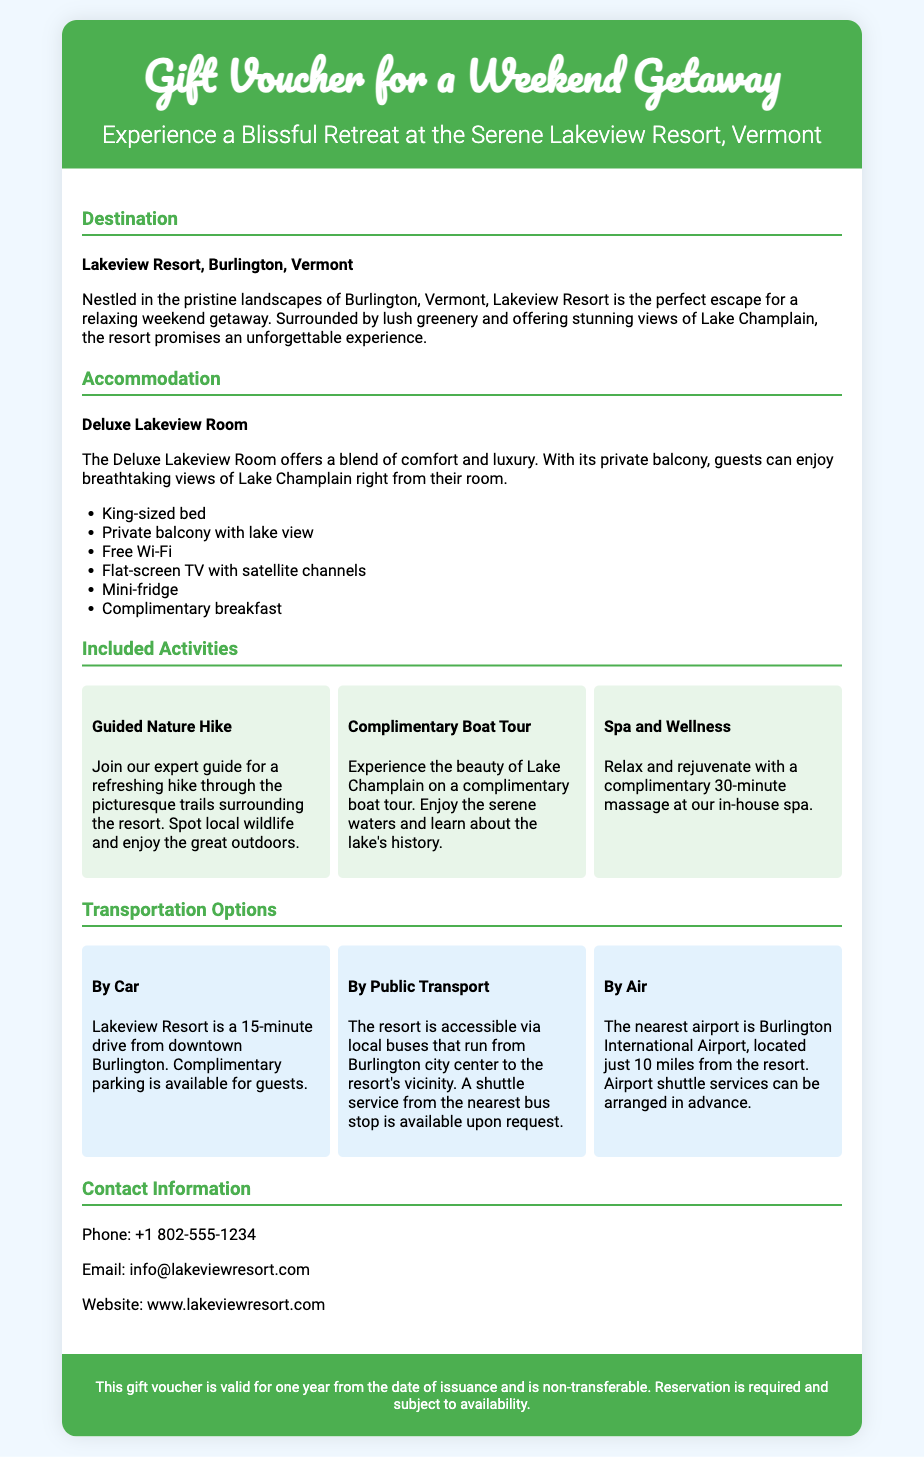what is the destination of the weekend getaway? The destination is mentioned in the header of the document, specifically stating "Lakeview Resort, Burlington, Vermont."
Answer: Lakeview Resort, Burlington, Vermont what type of room is included in the accommodation? The document specifies the accommodation type in the section about accommodation, which is "Deluxe Lakeview Room."
Answer: Deluxe Lakeview Room how many activities are included in the voucher? The document lists three specific activities under the "Included Activities" section.
Answer: Three what complimentary service is offered at the in-house spa? The document describes a specific service included in the activities, which is a massage.
Answer: 30-minute massage how far is the resort from the nearest airport? The document provides information about the airport distance in the transportation section, stating that it is "just 10 miles from the resort."
Answer: 10 miles what type of transport is available from Burlington city center? The document describes access to the resort via local buses in the transportation options.
Answer: Local buses what does the voucher mention about its validity? The footer of the voucher provides important details regarding the voucher's validity.
Answer: One year what is the private balcony designed to enhance? The document describes the private balcony in the accommodation section, emphasizing the views it offers.
Answer: Breathtaking views of Lake Champlain 